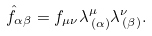<formula> <loc_0><loc_0><loc_500><loc_500>\hat { f } _ { \alpha \beta } = f _ { \mu \nu } \lambda ^ { \mu } _ { \, ( \alpha ) } \lambda ^ { \nu } _ { \, ( \beta ) } .</formula> 